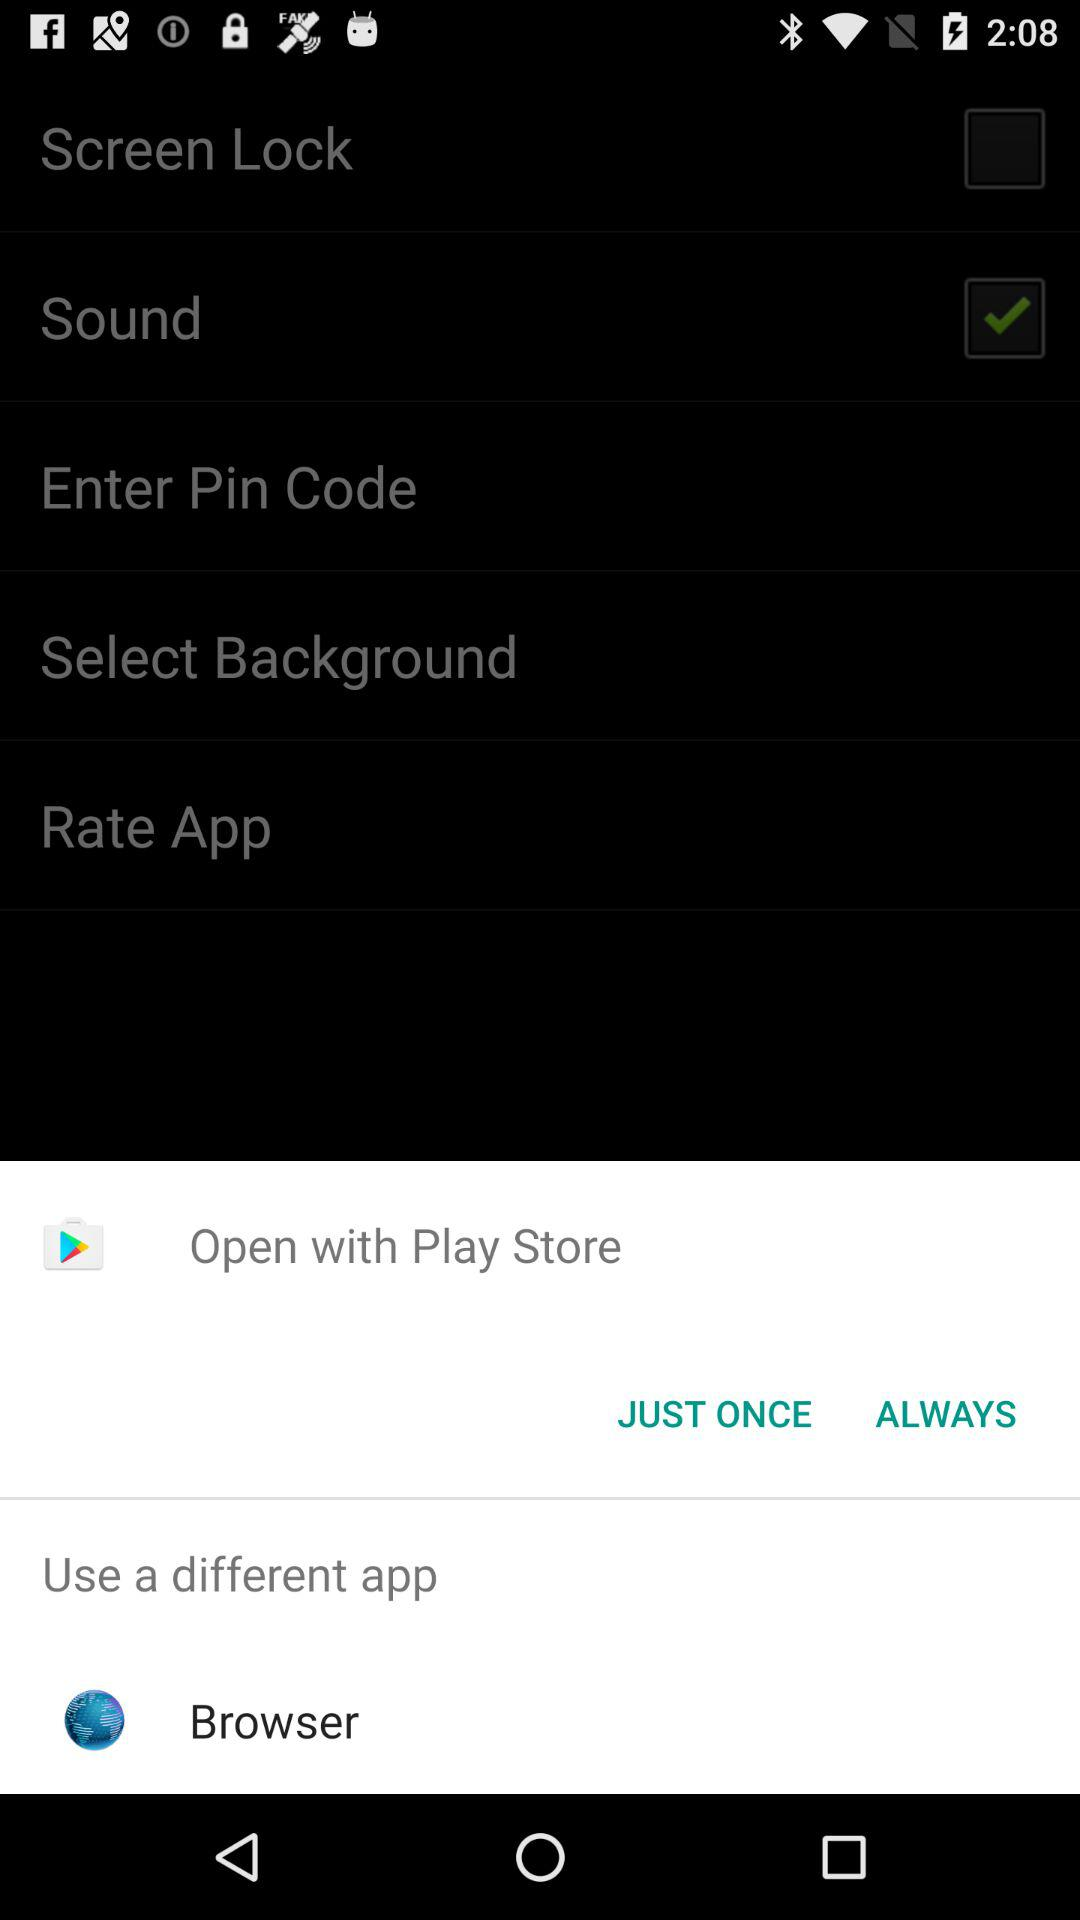What is the different app that can be used to open? The different app that can be used to open is "Browser". 